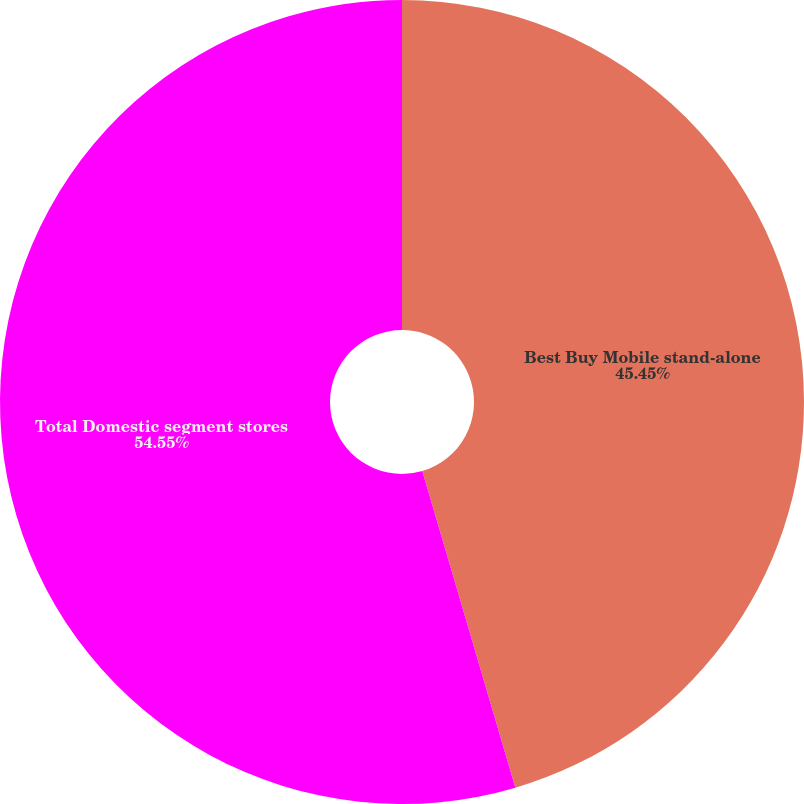Convert chart. <chart><loc_0><loc_0><loc_500><loc_500><pie_chart><fcel>Best Buy Mobile stand-alone<fcel>Total Domestic segment stores<nl><fcel>45.45%<fcel>54.55%<nl></chart> 